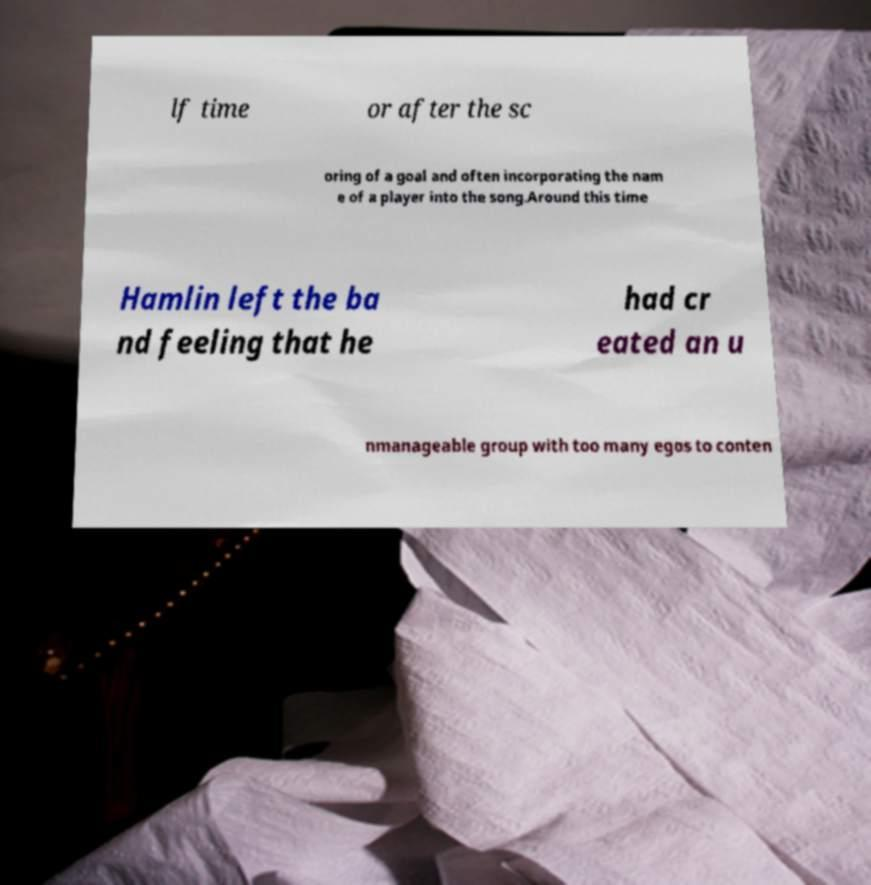Could you assist in decoding the text presented in this image and type it out clearly? lf time or after the sc oring of a goal and often incorporating the nam e of a player into the song.Around this time Hamlin left the ba nd feeling that he had cr eated an u nmanageable group with too many egos to conten 